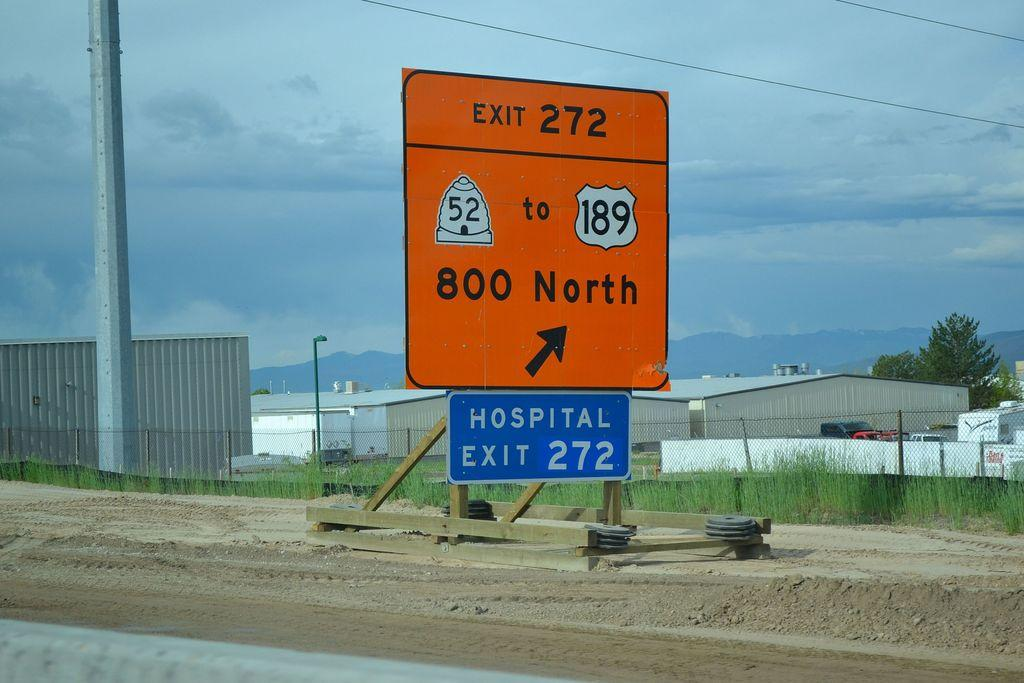<image>
Share a concise interpretation of the image provided. Orange exit sign for exit 272 where there is a hospital too. 